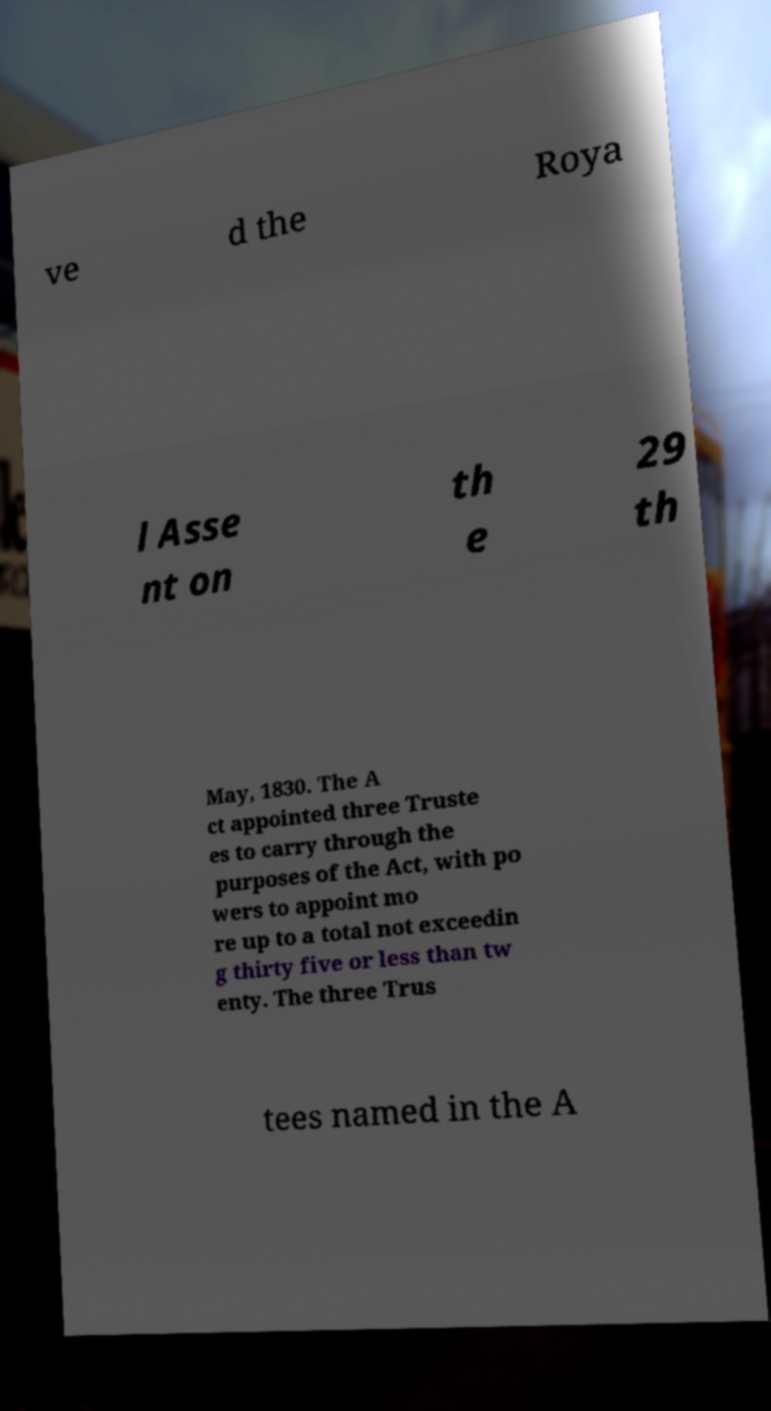Can you read and provide the text displayed in the image?This photo seems to have some interesting text. Can you extract and type it out for me? ve d the Roya l Asse nt on th e 29 th May, 1830. The A ct appointed three Truste es to carry through the purposes of the Act, with po wers to appoint mo re up to a total not exceedin g thirty five or less than tw enty. The three Trus tees named in the A 